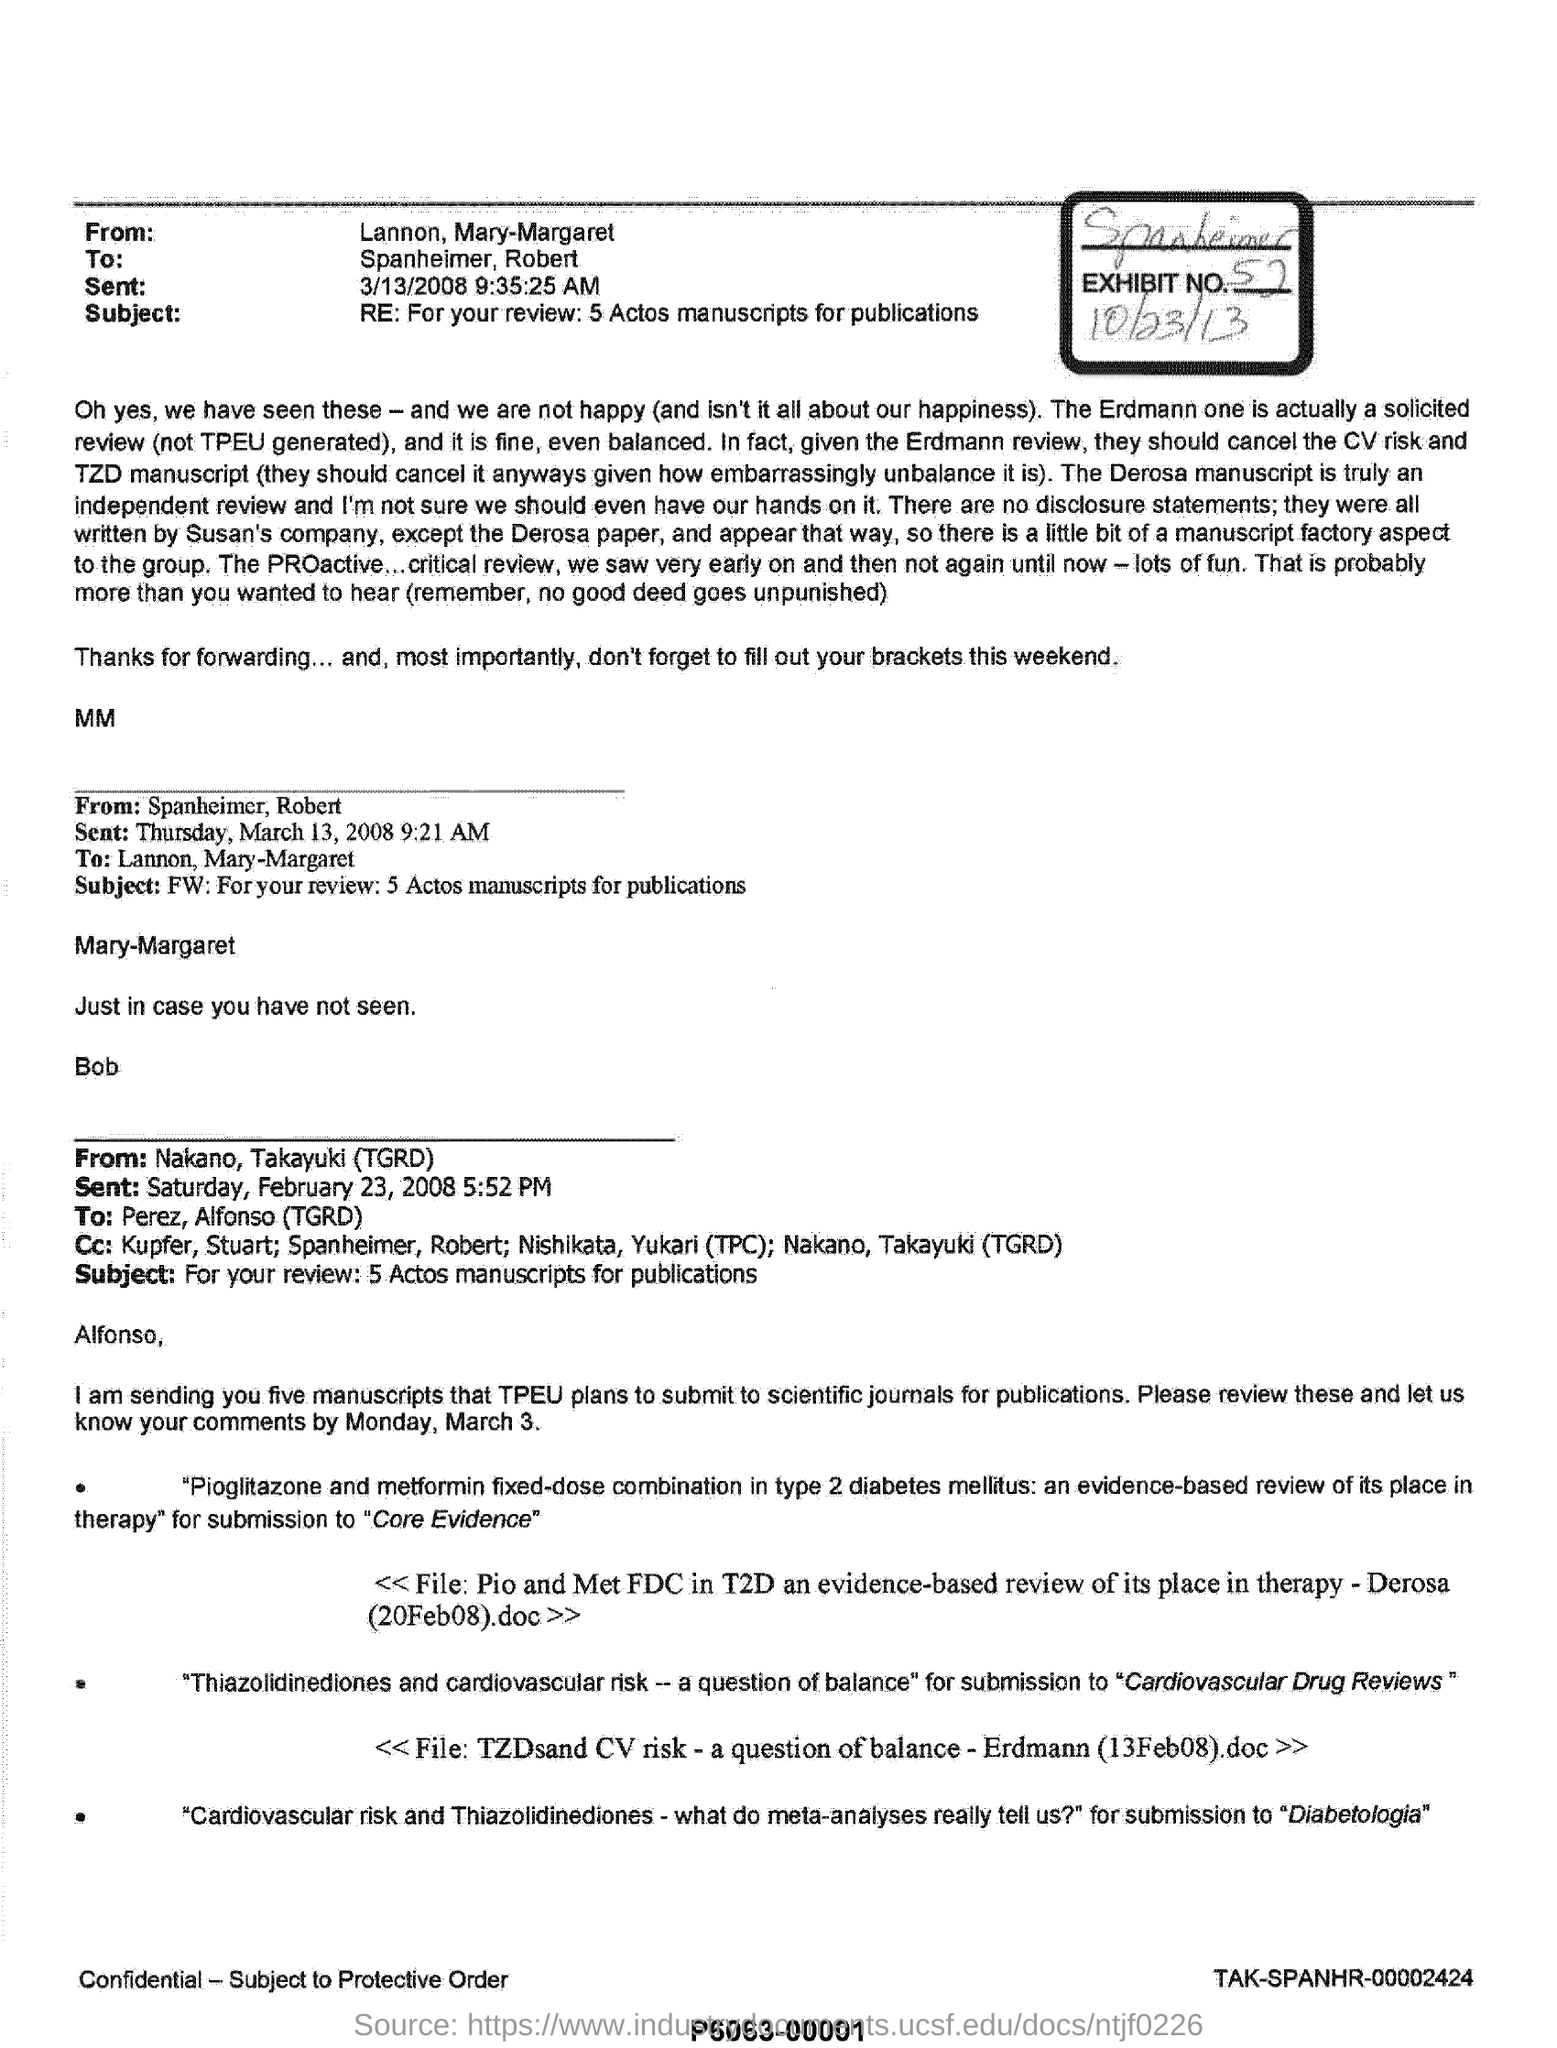List a handful of essential elements in this visual. The subject of the email from Lannon, Mary-Margaret is: "For your review: 5 Actos manuscripts for publications. The subject of the email from Nakano, Takayuki (TGRD) is requesting for review of 5 manuscripts for publication. The sent date and time of the email from Spanheimer, Robert is Thursday, March 13, 2008 9:21 AM. The sent date and time of the email from Lannon, Mary-Margaret was March 13, 2008 at 9:35:25 AM. 